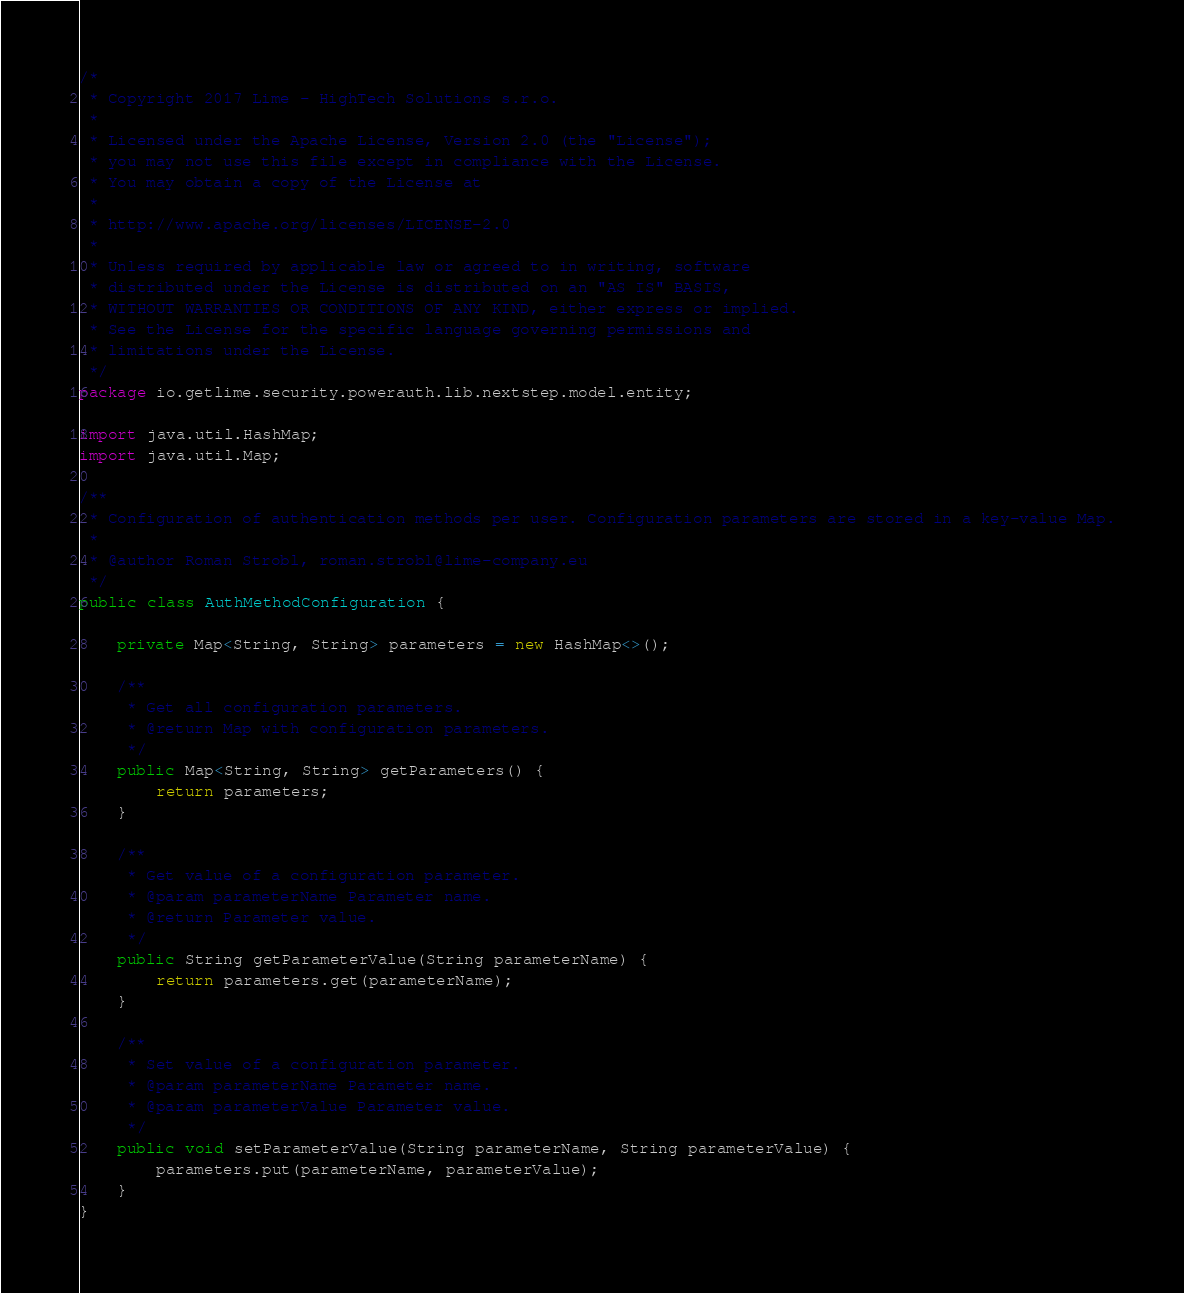Convert code to text. <code><loc_0><loc_0><loc_500><loc_500><_Java_>/*
 * Copyright 2017 Lime - HighTech Solutions s.r.o.
 *
 * Licensed under the Apache License, Version 2.0 (the "License");
 * you may not use this file except in compliance with the License.
 * You may obtain a copy of the License at
 *
 * http://www.apache.org/licenses/LICENSE-2.0
 *
 * Unless required by applicable law or agreed to in writing, software
 * distributed under the License is distributed on an "AS IS" BASIS,
 * WITHOUT WARRANTIES OR CONDITIONS OF ANY KIND, either express or implied.
 * See the License for the specific language governing permissions and
 * limitations under the License.
 */
package io.getlime.security.powerauth.lib.nextstep.model.entity;

import java.util.HashMap;
import java.util.Map;

/**
 * Configuration of authentication methods per user. Configuration parameters are stored in a key-value Map.
 *
 * @author Roman Strobl, roman.strobl@lime-company.eu
 */
public class AuthMethodConfiguration {

    private Map<String, String> parameters = new HashMap<>();

    /**
     * Get all configuration parameters.
     * @return Map with configuration parameters.
     */
    public Map<String, String> getParameters() {
        return parameters;
    }

    /**
     * Get value of a configuration parameter.
     * @param parameterName Parameter name.
     * @return Parameter value.
     */
    public String getParameterValue(String parameterName) {
        return parameters.get(parameterName);
    }

    /**
     * Set value of a configuration parameter.
     * @param parameterName Parameter name.
     * @param parameterValue Parameter value.
     */
    public void setParameterValue(String parameterName, String parameterValue) {
        parameters.put(parameterName, parameterValue);
    }
}
</code> 